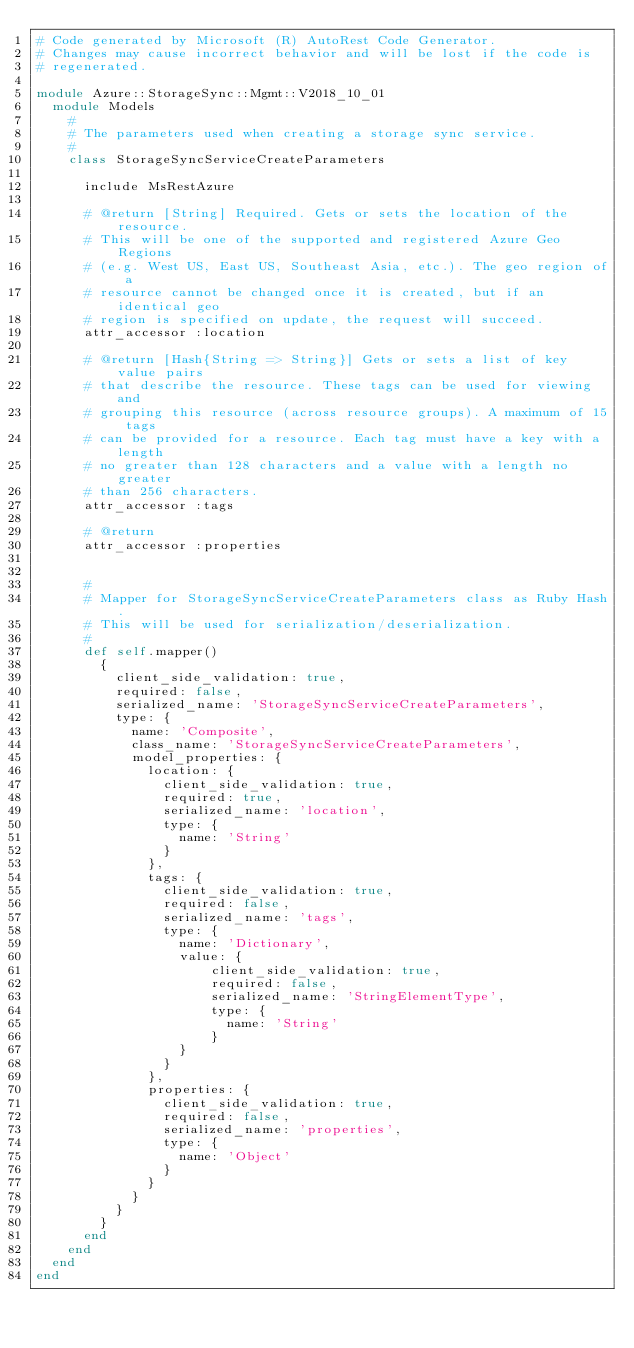<code> <loc_0><loc_0><loc_500><loc_500><_Ruby_># Code generated by Microsoft (R) AutoRest Code Generator.
# Changes may cause incorrect behavior and will be lost if the code is
# regenerated.

module Azure::StorageSync::Mgmt::V2018_10_01
  module Models
    #
    # The parameters used when creating a storage sync service.
    #
    class StorageSyncServiceCreateParameters

      include MsRestAzure

      # @return [String] Required. Gets or sets the location of the resource.
      # This will be one of the supported and registered Azure Geo Regions
      # (e.g. West US, East US, Southeast Asia, etc.). The geo region of a
      # resource cannot be changed once it is created, but if an identical geo
      # region is specified on update, the request will succeed.
      attr_accessor :location

      # @return [Hash{String => String}] Gets or sets a list of key value pairs
      # that describe the resource. These tags can be used for viewing and
      # grouping this resource (across resource groups). A maximum of 15 tags
      # can be provided for a resource. Each tag must have a key with a length
      # no greater than 128 characters and a value with a length no greater
      # than 256 characters.
      attr_accessor :tags

      # @return
      attr_accessor :properties


      #
      # Mapper for StorageSyncServiceCreateParameters class as Ruby Hash.
      # This will be used for serialization/deserialization.
      #
      def self.mapper()
        {
          client_side_validation: true,
          required: false,
          serialized_name: 'StorageSyncServiceCreateParameters',
          type: {
            name: 'Composite',
            class_name: 'StorageSyncServiceCreateParameters',
            model_properties: {
              location: {
                client_side_validation: true,
                required: true,
                serialized_name: 'location',
                type: {
                  name: 'String'
                }
              },
              tags: {
                client_side_validation: true,
                required: false,
                serialized_name: 'tags',
                type: {
                  name: 'Dictionary',
                  value: {
                      client_side_validation: true,
                      required: false,
                      serialized_name: 'StringElementType',
                      type: {
                        name: 'String'
                      }
                  }
                }
              },
              properties: {
                client_side_validation: true,
                required: false,
                serialized_name: 'properties',
                type: {
                  name: 'Object'
                }
              }
            }
          }
        }
      end
    end
  end
end
</code> 